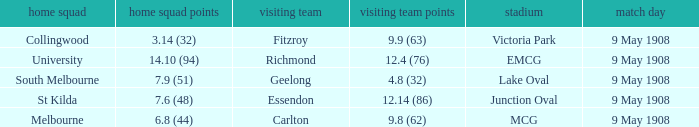Name the home team score for south melbourne home team 7.9 (51). 